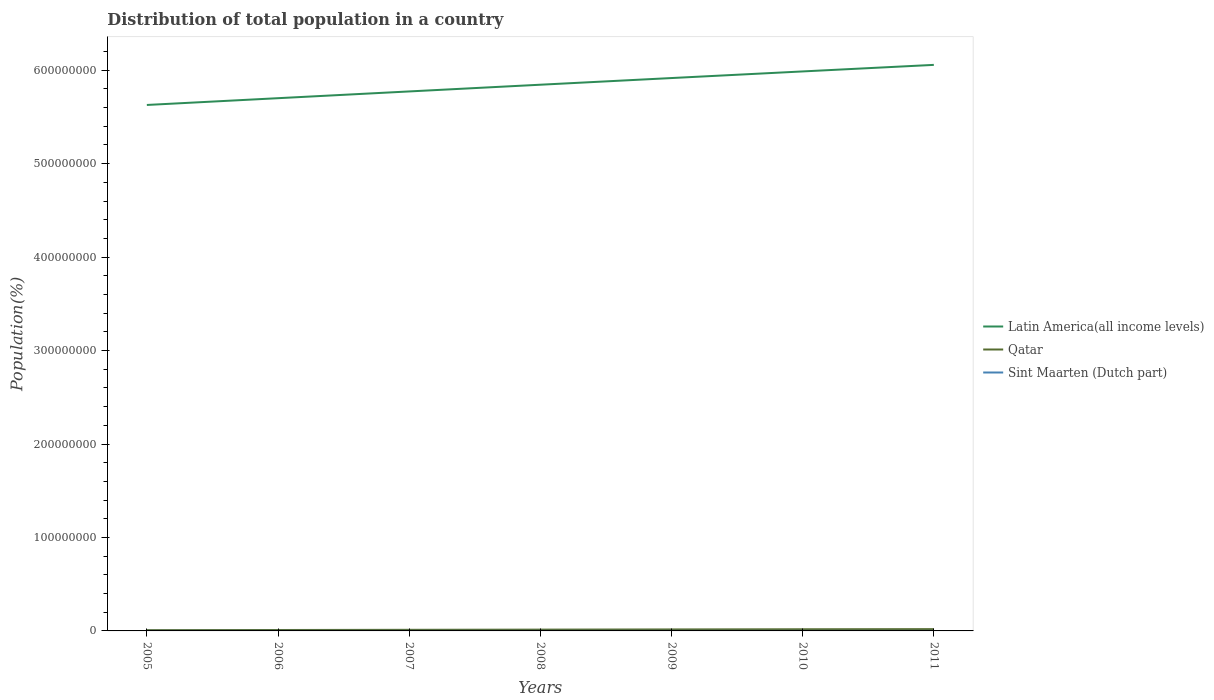Does the line corresponding to Sint Maarten (Dutch part) intersect with the line corresponding to Qatar?
Offer a terse response. No. Is the number of lines equal to the number of legend labels?
Ensure brevity in your answer.  Yes. Across all years, what is the maximum population of in Qatar?
Provide a succinct answer. 8.37e+05. In which year was the population of in Latin America(all income levels) maximum?
Give a very brief answer. 2005. What is the total population of in Sint Maarten (Dutch part) in the graph?
Make the answer very short. -1336. What is the difference between the highest and the second highest population of in Sint Maarten (Dutch part)?
Make the answer very short. 7023. What is the difference between the highest and the lowest population of in Sint Maarten (Dutch part)?
Make the answer very short. 4. Is the population of in Sint Maarten (Dutch part) strictly greater than the population of in Qatar over the years?
Provide a short and direct response. Yes. How many lines are there?
Provide a succinct answer. 3. How many years are there in the graph?
Your answer should be very brief. 7. Does the graph contain any zero values?
Your answer should be very brief. No. Does the graph contain grids?
Offer a terse response. No. How many legend labels are there?
Ensure brevity in your answer.  3. How are the legend labels stacked?
Provide a short and direct response. Vertical. What is the title of the graph?
Provide a succinct answer. Distribution of total population in a country. Does "Rwanda" appear as one of the legend labels in the graph?
Your answer should be very brief. No. What is the label or title of the X-axis?
Keep it short and to the point. Years. What is the label or title of the Y-axis?
Your answer should be compact. Population(%). What is the Population(%) of Latin America(all income levels) in 2005?
Your answer should be compact. 5.63e+08. What is the Population(%) of Qatar in 2005?
Give a very brief answer. 8.37e+05. What is the Population(%) of Sint Maarten (Dutch part) in 2005?
Your answer should be very brief. 3.69e+04. What is the Population(%) of Latin America(all income levels) in 2006?
Your answer should be compact. 5.70e+08. What is the Population(%) in Qatar in 2006?
Your answer should be compact. 9.88e+05. What is the Population(%) in Sint Maarten (Dutch part) in 2006?
Provide a short and direct response. 3.83e+04. What is the Population(%) in Latin America(all income levels) in 2007?
Your answer should be compact. 5.77e+08. What is the Population(%) in Qatar in 2007?
Provide a succinct answer. 1.18e+06. What is the Population(%) in Sint Maarten (Dutch part) in 2007?
Your answer should be very brief. 3.95e+04. What is the Population(%) of Latin America(all income levels) in 2008?
Make the answer very short. 5.84e+08. What is the Population(%) of Qatar in 2008?
Your answer should be very brief. 1.39e+06. What is the Population(%) of Sint Maarten (Dutch part) in 2008?
Offer a very short reply. 4.05e+04. What is the Population(%) of Latin America(all income levels) in 2009?
Provide a succinct answer. 5.92e+08. What is the Population(%) in Qatar in 2009?
Give a very brief answer. 1.59e+06. What is the Population(%) in Sint Maarten (Dutch part) in 2009?
Keep it short and to the point. 3.91e+04. What is the Population(%) in Latin America(all income levels) in 2010?
Offer a terse response. 5.99e+08. What is the Population(%) in Qatar in 2010?
Your answer should be very brief. 1.77e+06. What is the Population(%) in Sint Maarten (Dutch part) in 2010?
Give a very brief answer. 3.55e+04. What is the Population(%) in Latin America(all income levels) in 2011?
Provide a succinct answer. 6.06e+08. What is the Population(%) in Qatar in 2011?
Give a very brief answer. 1.91e+06. What is the Population(%) of Sint Maarten (Dutch part) in 2011?
Ensure brevity in your answer.  3.34e+04. Across all years, what is the maximum Population(%) in Latin America(all income levels)?
Make the answer very short. 6.06e+08. Across all years, what is the maximum Population(%) of Qatar?
Offer a terse response. 1.91e+06. Across all years, what is the maximum Population(%) in Sint Maarten (Dutch part)?
Keep it short and to the point. 4.05e+04. Across all years, what is the minimum Population(%) of Latin America(all income levels)?
Your response must be concise. 5.63e+08. Across all years, what is the minimum Population(%) in Qatar?
Provide a short and direct response. 8.37e+05. Across all years, what is the minimum Population(%) of Sint Maarten (Dutch part)?
Offer a terse response. 3.34e+04. What is the total Population(%) of Latin America(all income levels) in the graph?
Keep it short and to the point. 4.09e+09. What is the total Population(%) of Qatar in the graph?
Give a very brief answer. 9.66e+06. What is the total Population(%) in Sint Maarten (Dutch part) in the graph?
Offer a very short reply. 2.63e+05. What is the difference between the Population(%) of Latin America(all income levels) in 2005 and that in 2006?
Provide a succinct answer. -7.25e+06. What is the difference between the Population(%) of Qatar in 2005 and that in 2006?
Offer a terse response. -1.52e+05. What is the difference between the Population(%) of Sint Maarten (Dutch part) in 2005 and that in 2006?
Make the answer very short. -1336. What is the difference between the Population(%) of Latin America(all income levels) in 2005 and that in 2007?
Ensure brevity in your answer.  -1.45e+07. What is the difference between the Population(%) of Qatar in 2005 and that in 2007?
Keep it short and to the point. -3.42e+05. What is the difference between the Population(%) in Sint Maarten (Dutch part) in 2005 and that in 2007?
Your answer should be very brief. -2528. What is the difference between the Population(%) of Latin America(all income levels) in 2005 and that in 2008?
Your answer should be very brief. -2.17e+07. What is the difference between the Population(%) in Qatar in 2005 and that in 2008?
Make the answer very short. -5.52e+05. What is the difference between the Population(%) of Sint Maarten (Dutch part) in 2005 and that in 2008?
Offer a very short reply. -3524. What is the difference between the Population(%) in Latin America(all income levels) in 2005 and that in 2009?
Give a very brief answer. -2.88e+07. What is the difference between the Population(%) in Qatar in 2005 and that in 2009?
Provide a short and direct response. -7.54e+05. What is the difference between the Population(%) in Sint Maarten (Dutch part) in 2005 and that in 2009?
Your answer should be compact. -2199. What is the difference between the Population(%) in Latin America(all income levels) in 2005 and that in 2010?
Make the answer very short. -3.59e+07. What is the difference between the Population(%) in Qatar in 2005 and that in 2010?
Offer a very short reply. -9.29e+05. What is the difference between the Population(%) in Sint Maarten (Dutch part) in 2005 and that in 2010?
Provide a succinct answer. 1460. What is the difference between the Population(%) of Latin America(all income levels) in 2005 and that in 2011?
Your answer should be very brief. -4.29e+07. What is the difference between the Population(%) of Qatar in 2005 and that in 2011?
Offer a very short reply. -1.07e+06. What is the difference between the Population(%) of Sint Maarten (Dutch part) in 2005 and that in 2011?
Make the answer very short. 3499. What is the difference between the Population(%) of Latin America(all income levels) in 2006 and that in 2007?
Offer a terse response. -7.22e+06. What is the difference between the Population(%) of Qatar in 2006 and that in 2007?
Offer a very short reply. -1.91e+05. What is the difference between the Population(%) of Sint Maarten (Dutch part) in 2006 and that in 2007?
Your answer should be very brief. -1192. What is the difference between the Population(%) in Latin America(all income levels) in 2006 and that in 2008?
Offer a terse response. -1.44e+07. What is the difference between the Population(%) in Qatar in 2006 and that in 2008?
Keep it short and to the point. -4.01e+05. What is the difference between the Population(%) in Sint Maarten (Dutch part) in 2006 and that in 2008?
Your response must be concise. -2188. What is the difference between the Population(%) of Latin America(all income levels) in 2006 and that in 2009?
Offer a terse response. -2.15e+07. What is the difference between the Population(%) of Qatar in 2006 and that in 2009?
Provide a short and direct response. -6.03e+05. What is the difference between the Population(%) in Sint Maarten (Dutch part) in 2006 and that in 2009?
Ensure brevity in your answer.  -863. What is the difference between the Population(%) in Latin America(all income levels) in 2006 and that in 2010?
Offer a very short reply. -2.86e+07. What is the difference between the Population(%) of Qatar in 2006 and that in 2010?
Offer a very short reply. -7.77e+05. What is the difference between the Population(%) of Sint Maarten (Dutch part) in 2006 and that in 2010?
Offer a terse response. 2796. What is the difference between the Population(%) in Latin America(all income levels) in 2006 and that in 2011?
Provide a succinct answer. -3.56e+07. What is the difference between the Population(%) in Qatar in 2006 and that in 2011?
Offer a very short reply. -9.17e+05. What is the difference between the Population(%) of Sint Maarten (Dutch part) in 2006 and that in 2011?
Your answer should be very brief. 4835. What is the difference between the Population(%) in Latin America(all income levels) in 2007 and that in 2008?
Ensure brevity in your answer.  -7.19e+06. What is the difference between the Population(%) of Qatar in 2007 and that in 2008?
Ensure brevity in your answer.  -2.10e+05. What is the difference between the Population(%) in Sint Maarten (Dutch part) in 2007 and that in 2008?
Offer a very short reply. -996. What is the difference between the Population(%) in Latin America(all income levels) in 2007 and that in 2009?
Make the answer very short. -1.43e+07. What is the difference between the Population(%) in Qatar in 2007 and that in 2009?
Your response must be concise. -4.12e+05. What is the difference between the Population(%) of Sint Maarten (Dutch part) in 2007 and that in 2009?
Keep it short and to the point. 329. What is the difference between the Population(%) in Latin America(all income levels) in 2007 and that in 2010?
Offer a terse response. -2.14e+07. What is the difference between the Population(%) of Qatar in 2007 and that in 2010?
Offer a very short reply. -5.87e+05. What is the difference between the Population(%) of Sint Maarten (Dutch part) in 2007 and that in 2010?
Offer a terse response. 3988. What is the difference between the Population(%) in Latin America(all income levels) in 2007 and that in 2011?
Provide a short and direct response. -2.84e+07. What is the difference between the Population(%) of Qatar in 2007 and that in 2011?
Your answer should be compact. -7.26e+05. What is the difference between the Population(%) of Sint Maarten (Dutch part) in 2007 and that in 2011?
Provide a succinct answer. 6027. What is the difference between the Population(%) of Latin America(all income levels) in 2008 and that in 2009?
Keep it short and to the point. -7.14e+06. What is the difference between the Population(%) in Qatar in 2008 and that in 2009?
Keep it short and to the point. -2.02e+05. What is the difference between the Population(%) of Sint Maarten (Dutch part) in 2008 and that in 2009?
Give a very brief answer. 1325. What is the difference between the Population(%) of Latin America(all income levels) in 2008 and that in 2010?
Provide a succinct answer. -1.42e+07. What is the difference between the Population(%) in Qatar in 2008 and that in 2010?
Offer a very short reply. -3.77e+05. What is the difference between the Population(%) of Sint Maarten (Dutch part) in 2008 and that in 2010?
Offer a very short reply. 4984. What is the difference between the Population(%) of Latin America(all income levels) in 2008 and that in 2011?
Offer a terse response. -2.12e+07. What is the difference between the Population(%) in Qatar in 2008 and that in 2011?
Provide a short and direct response. -5.16e+05. What is the difference between the Population(%) in Sint Maarten (Dutch part) in 2008 and that in 2011?
Make the answer very short. 7023. What is the difference between the Population(%) in Latin America(all income levels) in 2009 and that in 2010?
Offer a very short reply. -7.09e+06. What is the difference between the Population(%) in Qatar in 2009 and that in 2010?
Make the answer very short. -1.74e+05. What is the difference between the Population(%) in Sint Maarten (Dutch part) in 2009 and that in 2010?
Your answer should be compact. 3659. What is the difference between the Population(%) of Latin America(all income levels) in 2009 and that in 2011?
Offer a terse response. -1.41e+07. What is the difference between the Population(%) in Qatar in 2009 and that in 2011?
Your answer should be very brief. -3.14e+05. What is the difference between the Population(%) in Sint Maarten (Dutch part) in 2009 and that in 2011?
Ensure brevity in your answer.  5698. What is the difference between the Population(%) in Latin America(all income levels) in 2010 and that in 2011?
Offer a very short reply. -7.01e+06. What is the difference between the Population(%) in Qatar in 2010 and that in 2011?
Provide a succinct answer. -1.40e+05. What is the difference between the Population(%) in Sint Maarten (Dutch part) in 2010 and that in 2011?
Your answer should be compact. 2039. What is the difference between the Population(%) of Latin America(all income levels) in 2005 and the Population(%) of Qatar in 2006?
Ensure brevity in your answer.  5.62e+08. What is the difference between the Population(%) in Latin America(all income levels) in 2005 and the Population(%) in Sint Maarten (Dutch part) in 2006?
Provide a succinct answer. 5.63e+08. What is the difference between the Population(%) of Qatar in 2005 and the Population(%) of Sint Maarten (Dutch part) in 2006?
Your answer should be compact. 7.99e+05. What is the difference between the Population(%) in Latin America(all income levels) in 2005 and the Population(%) in Qatar in 2007?
Give a very brief answer. 5.62e+08. What is the difference between the Population(%) in Latin America(all income levels) in 2005 and the Population(%) in Sint Maarten (Dutch part) in 2007?
Give a very brief answer. 5.63e+08. What is the difference between the Population(%) of Qatar in 2005 and the Population(%) of Sint Maarten (Dutch part) in 2007?
Keep it short and to the point. 7.97e+05. What is the difference between the Population(%) of Latin America(all income levels) in 2005 and the Population(%) of Qatar in 2008?
Provide a short and direct response. 5.61e+08. What is the difference between the Population(%) of Latin America(all income levels) in 2005 and the Population(%) of Sint Maarten (Dutch part) in 2008?
Offer a very short reply. 5.63e+08. What is the difference between the Population(%) in Qatar in 2005 and the Population(%) in Sint Maarten (Dutch part) in 2008?
Keep it short and to the point. 7.96e+05. What is the difference between the Population(%) of Latin America(all income levels) in 2005 and the Population(%) of Qatar in 2009?
Give a very brief answer. 5.61e+08. What is the difference between the Population(%) of Latin America(all income levels) in 2005 and the Population(%) of Sint Maarten (Dutch part) in 2009?
Provide a succinct answer. 5.63e+08. What is the difference between the Population(%) of Qatar in 2005 and the Population(%) of Sint Maarten (Dutch part) in 2009?
Your answer should be compact. 7.98e+05. What is the difference between the Population(%) of Latin America(all income levels) in 2005 and the Population(%) of Qatar in 2010?
Give a very brief answer. 5.61e+08. What is the difference between the Population(%) of Latin America(all income levels) in 2005 and the Population(%) of Sint Maarten (Dutch part) in 2010?
Your answer should be compact. 5.63e+08. What is the difference between the Population(%) of Qatar in 2005 and the Population(%) of Sint Maarten (Dutch part) in 2010?
Keep it short and to the point. 8.01e+05. What is the difference between the Population(%) in Latin America(all income levels) in 2005 and the Population(%) in Qatar in 2011?
Offer a terse response. 5.61e+08. What is the difference between the Population(%) in Latin America(all income levels) in 2005 and the Population(%) in Sint Maarten (Dutch part) in 2011?
Your answer should be compact. 5.63e+08. What is the difference between the Population(%) of Qatar in 2005 and the Population(%) of Sint Maarten (Dutch part) in 2011?
Your answer should be very brief. 8.03e+05. What is the difference between the Population(%) in Latin America(all income levels) in 2006 and the Population(%) in Qatar in 2007?
Your response must be concise. 5.69e+08. What is the difference between the Population(%) of Latin America(all income levels) in 2006 and the Population(%) of Sint Maarten (Dutch part) in 2007?
Provide a short and direct response. 5.70e+08. What is the difference between the Population(%) of Qatar in 2006 and the Population(%) of Sint Maarten (Dutch part) in 2007?
Provide a succinct answer. 9.49e+05. What is the difference between the Population(%) in Latin America(all income levels) in 2006 and the Population(%) in Qatar in 2008?
Give a very brief answer. 5.69e+08. What is the difference between the Population(%) of Latin America(all income levels) in 2006 and the Population(%) of Sint Maarten (Dutch part) in 2008?
Keep it short and to the point. 5.70e+08. What is the difference between the Population(%) of Qatar in 2006 and the Population(%) of Sint Maarten (Dutch part) in 2008?
Offer a very short reply. 9.48e+05. What is the difference between the Population(%) in Latin America(all income levels) in 2006 and the Population(%) in Qatar in 2009?
Your response must be concise. 5.68e+08. What is the difference between the Population(%) of Latin America(all income levels) in 2006 and the Population(%) of Sint Maarten (Dutch part) in 2009?
Give a very brief answer. 5.70e+08. What is the difference between the Population(%) of Qatar in 2006 and the Population(%) of Sint Maarten (Dutch part) in 2009?
Give a very brief answer. 9.49e+05. What is the difference between the Population(%) of Latin America(all income levels) in 2006 and the Population(%) of Qatar in 2010?
Ensure brevity in your answer.  5.68e+08. What is the difference between the Population(%) in Latin America(all income levels) in 2006 and the Population(%) in Sint Maarten (Dutch part) in 2010?
Offer a terse response. 5.70e+08. What is the difference between the Population(%) in Qatar in 2006 and the Population(%) in Sint Maarten (Dutch part) in 2010?
Provide a short and direct response. 9.53e+05. What is the difference between the Population(%) of Latin America(all income levels) in 2006 and the Population(%) of Qatar in 2011?
Provide a short and direct response. 5.68e+08. What is the difference between the Population(%) of Latin America(all income levels) in 2006 and the Population(%) of Sint Maarten (Dutch part) in 2011?
Give a very brief answer. 5.70e+08. What is the difference between the Population(%) in Qatar in 2006 and the Population(%) in Sint Maarten (Dutch part) in 2011?
Offer a very short reply. 9.55e+05. What is the difference between the Population(%) in Latin America(all income levels) in 2007 and the Population(%) in Qatar in 2008?
Offer a very short reply. 5.76e+08. What is the difference between the Population(%) in Latin America(all income levels) in 2007 and the Population(%) in Sint Maarten (Dutch part) in 2008?
Make the answer very short. 5.77e+08. What is the difference between the Population(%) of Qatar in 2007 and the Population(%) of Sint Maarten (Dutch part) in 2008?
Your answer should be very brief. 1.14e+06. What is the difference between the Population(%) in Latin America(all income levels) in 2007 and the Population(%) in Qatar in 2009?
Your answer should be compact. 5.76e+08. What is the difference between the Population(%) of Latin America(all income levels) in 2007 and the Population(%) of Sint Maarten (Dutch part) in 2009?
Your answer should be compact. 5.77e+08. What is the difference between the Population(%) of Qatar in 2007 and the Population(%) of Sint Maarten (Dutch part) in 2009?
Keep it short and to the point. 1.14e+06. What is the difference between the Population(%) in Latin America(all income levels) in 2007 and the Population(%) in Qatar in 2010?
Your response must be concise. 5.75e+08. What is the difference between the Population(%) in Latin America(all income levels) in 2007 and the Population(%) in Sint Maarten (Dutch part) in 2010?
Ensure brevity in your answer.  5.77e+08. What is the difference between the Population(%) in Qatar in 2007 and the Population(%) in Sint Maarten (Dutch part) in 2010?
Your response must be concise. 1.14e+06. What is the difference between the Population(%) in Latin America(all income levels) in 2007 and the Population(%) in Qatar in 2011?
Provide a succinct answer. 5.75e+08. What is the difference between the Population(%) of Latin America(all income levels) in 2007 and the Population(%) of Sint Maarten (Dutch part) in 2011?
Offer a terse response. 5.77e+08. What is the difference between the Population(%) in Qatar in 2007 and the Population(%) in Sint Maarten (Dutch part) in 2011?
Your response must be concise. 1.15e+06. What is the difference between the Population(%) in Latin America(all income levels) in 2008 and the Population(%) in Qatar in 2009?
Keep it short and to the point. 5.83e+08. What is the difference between the Population(%) of Latin America(all income levels) in 2008 and the Population(%) of Sint Maarten (Dutch part) in 2009?
Your response must be concise. 5.84e+08. What is the difference between the Population(%) of Qatar in 2008 and the Population(%) of Sint Maarten (Dutch part) in 2009?
Provide a short and direct response. 1.35e+06. What is the difference between the Population(%) of Latin America(all income levels) in 2008 and the Population(%) of Qatar in 2010?
Ensure brevity in your answer.  5.83e+08. What is the difference between the Population(%) of Latin America(all income levels) in 2008 and the Population(%) of Sint Maarten (Dutch part) in 2010?
Your response must be concise. 5.84e+08. What is the difference between the Population(%) in Qatar in 2008 and the Population(%) in Sint Maarten (Dutch part) in 2010?
Keep it short and to the point. 1.35e+06. What is the difference between the Population(%) of Latin America(all income levels) in 2008 and the Population(%) of Qatar in 2011?
Ensure brevity in your answer.  5.83e+08. What is the difference between the Population(%) in Latin America(all income levels) in 2008 and the Population(%) in Sint Maarten (Dutch part) in 2011?
Give a very brief answer. 5.84e+08. What is the difference between the Population(%) in Qatar in 2008 and the Population(%) in Sint Maarten (Dutch part) in 2011?
Your response must be concise. 1.36e+06. What is the difference between the Population(%) of Latin America(all income levels) in 2009 and the Population(%) of Qatar in 2010?
Offer a terse response. 5.90e+08. What is the difference between the Population(%) in Latin America(all income levels) in 2009 and the Population(%) in Sint Maarten (Dutch part) in 2010?
Provide a succinct answer. 5.92e+08. What is the difference between the Population(%) of Qatar in 2009 and the Population(%) of Sint Maarten (Dutch part) in 2010?
Make the answer very short. 1.56e+06. What is the difference between the Population(%) of Latin America(all income levels) in 2009 and the Population(%) of Qatar in 2011?
Offer a terse response. 5.90e+08. What is the difference between the Population(%) of Latin America(all income levels) in 2009 and the Population(%) of Sint Maarten (Dutch part) in 2011?
Offer a terse response. 5.92e+08. What is the difference between the Population(%) of Qatar in 2009 and the Population(%) of Sint Maarten (Dutch part) in 2011?
Give a very brief answer. 1.56e+06. What is the difference between the Population(%) of Latin America(all income levels) in 2010 and the Population(%) of Qatar in 2011?
Provide a short and direct response. 5.97e+08. What is the difference between the Population(%) in Latin America(all income levels) in 2010 and the Population(%) in Sint Maarten (Dutch part) in 2011?
Your answer should be compact. 5.99e+08. What is the difference between the Population(%) in Qatar in 2010 and the Population(%) in Sint Maarten (Dutch part) in 2011?
Offer a very short reply. 1.73e+06. What is the average Population(%) of Latin America(all income levels) per year?
Your answer should be very brief. 5.84e+08. What is the average Population(%) in Qatar per year?
Provide a succinct answer. 1.38e+06. What is the average Population(%) in Sint Maarten (Dutch part) per year?
Your response must be concise. 3.76e+04. In the year 2005, what is the difference between the Population(%) in Latin America(all income levels) and Population(%) in Qatar?
Give a very brief answer. 5.62e+08. In the year 2005, what is the difference between the Population(%) in Latin America(all income levels) and Population(%) in Sint Maarten (Dutch part)?
Provide a succinct answer. 5.63e+08. In the year 2005, what is the difference between the Population(%) of Qatar and Population(%) of Sint Maarten (Dutch part)?
Keep it short and to the point. 8.00e+05. In the year 2006, what is the difference between the Population(%) in Latin America(all income levels) and Population(%) in Qatar?
Your answer should be very brief. 5.69e+08. In the year 2006, what is the difference between the Population(%) in Latin America(all income levels) and Population(%) in Sint Maarten (Dutch part)?
Give a very brief answer. 5.70e+08. In the year 2006, what is the difference between the Population(%) of Qatar and Population(%) of Sint Maarten (Dutch part)?
Your response must be concise. 9.50e+05. In the year 2007, what is the difference between the Population(%) of Latin America(all income levels) and Population(%) of Qatar?
Provide a succinct answer. 5.76e+08. In the year 2007, what is the difference between the Population(%) of Latin America(all income levels) and Population(%) of Sint Maarten (Dutch part)?
Ensure brevity in your answer.  5.77e+08. In the year 2007, what is the difference between the Population(%) in Qatar and Population(%) in Sint Maarten (Dutch part)?
Provide a short and direct response. 1.14e+06. In the year 2008, what is the difference between the Population(%) in Latin America(all income levels) and Population(%) in Qatar?
Your response must be concise. 5.83e+08. In the year 2008, what is the difference between the Population(%) in Latin America(all income levels) and Population(%) in Sint Maarten (Dutch part)?
Provide a short and direct response. 5.84e+08. In the year 2008, what is the difference between the Population(%) in Qatar and Population(%) in Sint Maarten (Dutch part)?
Offer a terse response. 1.35e+06. In the year 2009, what is the difference between the Population(%) in Latin America(all income levels) and Population(%) in Qatar?
Offer a terse response. 5.90e+08. In the year 2009, what is the difference between the Population(%) in Latin America(all income levels) and Population(%) in Sint Maarten (Dutch part)?
Your answer should be very brief. 5.92e+08. In the year 2009, what is the difference between the Population(%) in Qatar and Population(%) in Sint Maarten (Dutch part)?
Give a very brief answer. 1.55e+06. In the year 2010, what is the difference between the Population(%) of Latin America(all income levels) and Population(%) of Qatar?
Your answer should be compact. 5.97e+08. In the year 2010, what is the difference between the Population(%) in Latin America(all income levels) and Population(%) in Sint Maarten (Dutch part)?
Offer a very short reply. 5.99e+08. In the year 2010, what is the difference between the Population(%) of Qatar and Population(%) of Sint Maarten (Dutch part)?
Make the answer very short. 1.73e+06. In the year 2011, what is the difference between the Population(%) of Latin America(all income levels) and Population(%) of Qatar?
Ensure brevity in your answer.  6.04e+08. In the year 2011, what is the difference between the Population(%) in Latin America(all income levels) and Population(%) in Sint Maarten (Dutch part)?
Give a very brief answer. 6.06e+08. In the year 2011, what is the difference between the Population(%) in Qatar and Population(%) in Sint Maarten (Dutch part)?
Make the answer very short. 1.87e+06. What is the ratio of the Population(%) of Latin America(all income levels) in 2005 to that in 2006?
Your response must be concise. 0.99. What is the ratio of the Population(%) of Qatar in 2005 to that in 2006?
Your answer should be compact. 0.85. What is the ratio of the Population(%) in Sint Maarten (Dutch part) in 2005 to that in 2006?
Keep it short and to the point. 0.97. What is the ratio of the Population(%) in Latin America(all income levels) in 2005 to that in 2007?
Your response must be concise. 0.97. What is the ratio of the Population(%) in Qatar in 2005 to that in 2007?
Offer a terse response. 0.71. What is the ratio of the Population(%) in Sint Maarten (Dutch part) in 2005 to that in 2007?
Keep it short and to the point. 0.94. What is the ratio of the Population(%) in Latin America(all income levels) in 2005 to that in 2008?
Keep it short and to the point. 0.96. What is the ratio of the Population(%) of Qatar in 2005 to that in 2008?
Offer a terse response. 0.6. What is the ratio of the Population(%) in Sint Maarten (Dutch part) in 2005 to that in 2008?
Give a very brief answer. 0.91. What is the ratio of the Population(%) in Latin America(all income levels) in 2005 to that in 2009?
Give a very brief answer. 0.95. What is the ratio of the Population(%) of Qatar in 2005 to that in 2009?
Your answer should be compact. 0.53. What is the ratio of the Population(%) in Sint Maarten (Dutch part) in 2005 to that in 2009?
Make the answer very short. 0.94. What is the ratio of the Population(%) in Latin America(all income levels) in 2005 to that in 2010?
Give a very brief answer. 0.94. What is the ratio of the Population(%) in Qatar in 2005 to that in 2010?
Make the answer very short. 0.47. What is the ratio of the Population(%) in Sint Maarten (Dutch part) in 2005 to that in 2010?
Ensure brevity in your answer.  1.04. What is the ratio of the Population(%) of Latin America(all income levels) in 2005 to that in 2011?
Your answer should be very brief. 0.93. What is the ratio of the Population(%) in Qatar in 2005 to that in 2011?
Provide a succinct answer. 0.44. What is the ratio of the Population(%) in Sint Maarten (Dutch part) in 2005 to that in 2011?
Give a very brief answer. 1.1. What is the ratio of the Population(%) of Latin America(all income levels) in 2006 to that in 2007?
Your response must be concise. 0.99. What is the ratio of the Population(%) in Qatar in 2006 to that in 2007?
Your answer should be very brief. 0.84. What is the ratio of the Population(%) of Sint Maarten (Dutch part) in 2006 to that in 2007?
Provide a short and direct response. 0.97. What is the ratio of the Population(%) in Latin America(all income levels) in 2006 to that in 2008?
Make the answer very short. 0.98. What is the ratio of the Population(%) in Qatar in 2006 to that in 2008?
Ensure brevity in your answer.  0.71. What is the ratio of the Population(%) in Sint Maarten (Dutch part) in 2006 to that in 2008?
Your response must be concise. 0.95. What is the ratio of the Population(%) of Latin America(all income levels) in 2006 to that in 2009?
Provide a succinct answer. 0.96. What is the ratio of the Population(%) in Qatar in 2006 to that in 2009?
Ensure brevity in your answer.  0.62. What is the ratio of the Population(%) in Sint Maarten (Dutch part) in 2006 to that in 2009?
Offer a terse response. 0.98. What is the ratio of the Population(%) in Latin America(all income levels) in 2006 to that in 2010?
Provide a succinct answer. 0.95. What is the ratio of the Population(%) of Qatar in 2006 to that in 2010?
Your answer should be very brief. 0.56. What is the ratio of the Population(%) of Sint Maarten (Dutch part) in 2006 to that in 2010?
Your answer should be compact. 1.08. What is the ratio of the Population(%) of Latin America(all income levels) in 2006 to that in 2011?
Offer a terse response. 0.94. What is the ratio of the Population(%) of Qatar in 2006 to that in 2011?
Offer a very short reply. 0.52. What is the ratio of the Population(%) in Sint Maarten (Dutch part) in 2006 to that in 2011?
Your answer should be compact. 1.14. What is the ratio of the Population(%) of Latin America(all income levels) in 2007 to that in 2008?
Your answer should be very brief. 0.99. What is the ratio of the Population(%) of Qatar in 2007 to that in 2008?
Offer a terse response. 0.85. What is the ratio of the Population(%) of Sint Maarten (Dutch part) in 2007 to that in 2008?
Your response must be concise. 0.98. What is the ratio of the Population(%) in Latin America(all income levels) in 2007 to that in 2009?
Offer a terse response. 0.98. What is the ratio of the Population(%) in Qatar in 2007 to that in 2009?
Ensure brevity in your answer.  0.74. What is the ratio of the Population(%) of Sint Maarten (Dutch part) in 2007 to that in 2009?
Keep it short and to the point. 1.01. What is the ratio of the Population(%) of Latin America(all income levels) in 2007 to that in 2010?
Offer a terse response. 0.96. What is the ratio of the Population(%) of Qatar in 2007 to that in 2010?
Give a very brief answer. 0.67. What is the ratio of the Population(%) in Sint Maarten (Dutch part) in 2007 to that in 2010?
Your response must be concise. 1.11. What is the ratio of the Population(%) in Latin America(all income levels) in 2007 to that in 2011?
Provide a short and direct response. 0.95. What is the ratio of the Population(%) of Qatar in 2007 to that in 2011?
Keep it short and to the point. 0.62. What is the ratio of the Population(%) in Sint Maarten (Dutch part) in 2007 to that in 2011?
Offer a terse response. 1.18. What is the ratio of the Population(%) of Latin America(all income levels) in 2008 to that in 2009?
Offer a very short reply. 0.99. What is the ratio of the Population(%) in Qatar in 2008 to that in 2009?
Offer a very short reply. 0.87. What is the ratio of the Population(%) in Sint Maarten (Dutch part) in 2008 to that in 2009?
Your answer should be compact. 1.03. What is the ratio of the Population(%) in Latin America(all income levels) in 2008 to that in 2010?
Your answer should be compact. 0.98. What is the ratio of the Population(%) of Qatar in 2008 to that in 2010?
Give a very brief answer. 0.79. What is the ratio of the Population(%) of Sint Maarten (Dutch part) in 2008 to that in 2010?
Provide a succinct answer. 1.14. What is the ratio of the Population(%) of Latin America(all income levels) in 2008 to that in 2011?
Your response must be concise. 0.96. What is the ratio of the Population(%) in Qatar in 2008 to that in 2011?
Ensure brevity in your answer.  0.73. What is the ratio of the Population(%) of Sint Maarten (Dutch part) in 2008 to that in 2011?
Provide a succinct answer. 1.21. What is the ratio of the Population(%) of Latin America(all income levels) in 2009 to that in 2010?
Provide a short and direct response. 0.99. What is the ratio of the Population(%) in Qatar in 2009 to that in 2010?
Your answer should be compact. 0.9. What is the ratio of the Population(%) of Sint Maarten (Dutch part) in 2009 to that in 2010?
Provide a succinct answer. 1.1. What is the ratio of the Population(%) of Latin America(all income levels) in 2009 to that in 2011?
Your answer should be compact. 0.98. What is the ratio of the Population(%) in Qatar in 2009 to that in 2011?
Offer a very short reply. 0.84. What is the ratio of the Population(%) in Sint Maarten (Dutch part) in 2009 to that in 2011?
Your answer should be compact. 1.17. What is the ratio of the Population(%) of Latin America(all income levels) in 2010 to that in 2011?
Give a very brief answer. 0.99. What is the ratio of the Population(%) of Qatar in 2010 to that in 2011?
Keep it short and to the point. 0.93. What is the ratio of the Population(%) of Sint Maarten (Dutch part) in 2010 to that in 2011?
Make the answer very short. 1.06. What is the difference between the highest and the second highest Population(%) of Latin America(all income levels)?
Keep it short and to the point. 7.01e+06. What is the difference between the highest and the second highest Population(%) in Qatar?
Provide a short and direct response. 1.40e+05. What is the difference between the highest and the second highest Population(%) of Sint Maarten (Dutch part)?
Make the answer very short. 996. What is the difference between the highest and the lowest Population(%) of Latin America(all income levels)?
Give a very brief answer. 4.29e+07. What is the difference between the highest and the lowest Population(%) of Qatar?
Provide a succinct answer. 1.07e+06. What is the difference between the highest and the lowest Population(%) of Sint Maarten (Dutch part)?
Your answer should be very brief. 7023. 